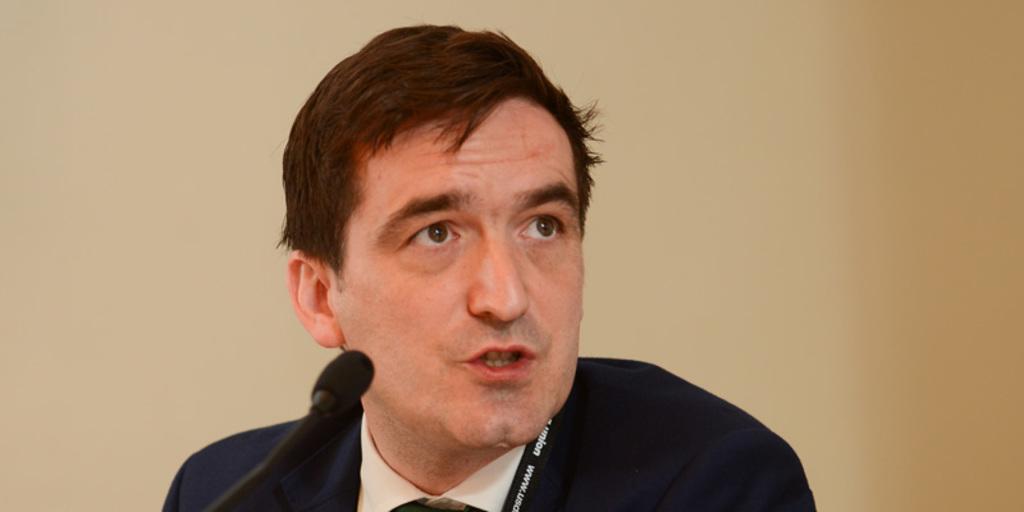Please provide a concise description of this image. In this image in the front there is a mic and there is a person speaking on the mic. 